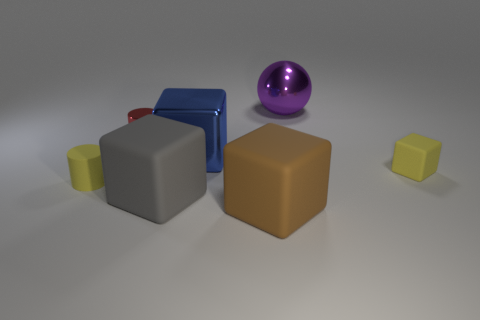Subtract all shiny cubes. How many cubes are left? 3 Add 3 big purple cubes. How many objects exist? 10 Subtract all yellow cubes. How many cubes are left? 3 Subtract 1 cubes. How many cubes are left? 3 Add 2 big balls. How many big balls are left? 3 Add 4 red metal cylinders. How many red metal cylinders exist? 5 Subtract 0 green balls. How many objects are left? 7 Subtract all spheres. How many objects are left? 6 Subtract all gray cubes. Subtract all brown cylinders. How many cubes are left? 3 Subtract all large purple spheres. Subtract all big spheres. How many objects are left? 5 